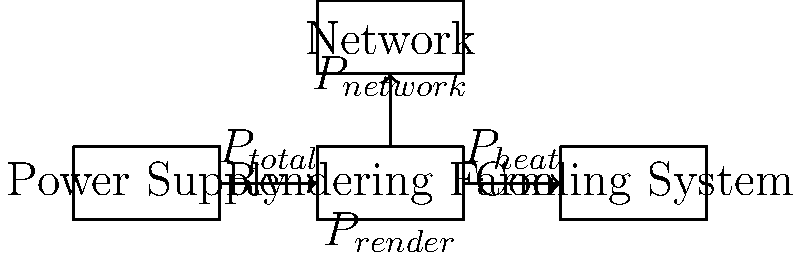In a rendering farm used for creating Pixar's latest animated feature, the power consumption is distributed among various components. Using the block diagram provided, which represents the major power-consuming elements in watts (W), determine the total power consumed by the rendering process ($P_{render}$) if:

- Total power supplied ($P_{total}$) = 10,000 W
- Power consumed by cooling system ($P_{heat}$) = 3,000 W
- Power consumed by network equipment ($P_{network}$) = 500 W

Assume all power not accounted for by cooling and networking is used in the rendering process. To solve this problem, we'll follow these steps:

1. Identify the given values:
   $P_{total}$ = 10,000 W
   $P_{heat}$ = 3,000 W
   $P_{network}$ = 500 W

2. Understand the power distribution:
   The total power ($P_{total}$) is divided among the rendering farm, cooling system, and network.

3. Set up the equation:
   $P_{total}$ = $P_{render}$ + $P_{heat}$ + $P_{network}$

4. Rearrange the equation to solve for $P_{render}$:
   $P_{render}$ = $P_{total}$ - $P_{heat}$ - $P_{network}$

5. Substitute the known values:
   $P_{render}$ = 10,000 W - 3,000 W - 500 W

6. Calculate the result:
   $P_{render}$ = 6,500 W

Therefore, the power consumed by the rendering process is 6,500 W.
Answer: 6,500 W 